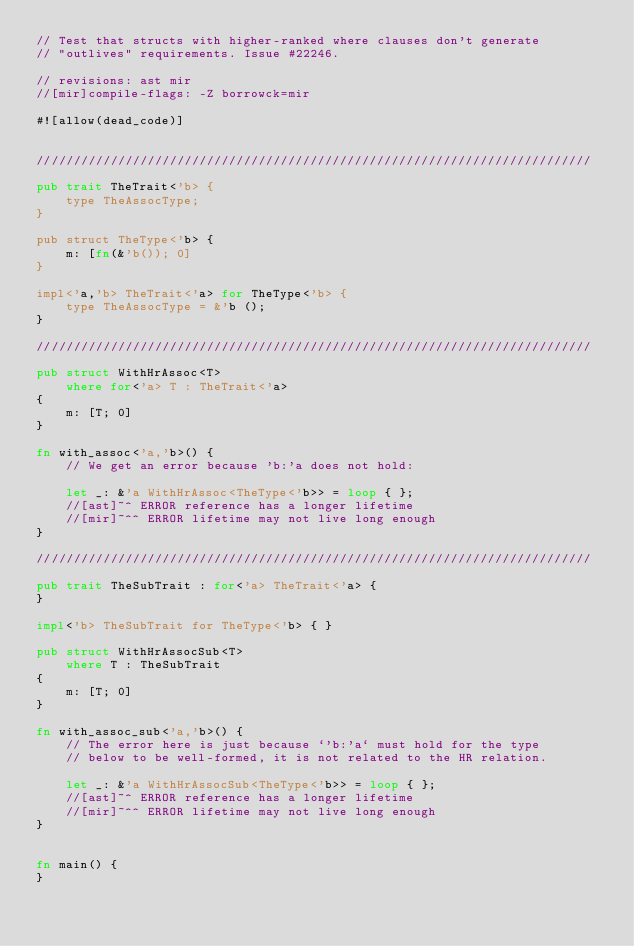Convert code to text. <code><loc_0><loc_0><loc_500><loc_500><_Rust_>// Test that structs with higher-ranked where clauses don't generate
// "outlives" requirements. Issue #22246.

// revisions: ast mir
//[mir]compile-flags: -Z borrowck=mir

#![allow(dead_code)]


///////////////////////////////////////////////////////////////////////////

pub trait TheTrait<'b> {
    type TheAssocType;
}

pub struct TheType<'b> {
    m: [fn(&'b()); 0]
}

impl<'a,'b> TheTrait<'a> for TheType<'b> {
    type TheAssocType = &'b ();
}

///////////////////////////////////////////////////////////////////////////

pub struct WithHrAssoc<T>
    where for<'a> T : TheTrait<'a>
{
    m: [T; 0]
}

fn with_assoc<'a,'b>() {
    // We get an error because 'b:'a does not hold:

    let _: &'a WithHrAssoc<TheType<'b>> = loop { };
    //[ast]~^ ERROR reference has a longer lifetime
    //[mir]~^^ ERROR lifetime may not live long enough
}

///////////////////////////////////////////////////////////////////////////

pub trait TheSubTrait : for<'a> TheTrait<'a> {
}

impl<'b> TheSubTrait for TheType<'b> { }

pub struct WithHrAssocSub<T>
    where T : TheSubTrait
{
    m: [T; 0]
}

fn with_assoc_sub<'a,'b>() {
    // The error here is just because `'b:'a` must hold for the type
    // below to be well-formed, it is not related to the HR relation.

    let _: &'a WithHrAssocSub<TheType<'b>> = loop { };
    //[ast]~^ ERROR reference has a longer lifetime
    //[mir]~^^ ERROR lifetime may not live long enough
}


fn main() {
}
</code> 